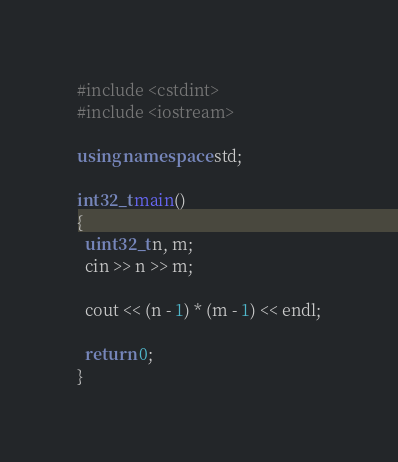Convert code to text. <code><loc_0><loc_0><loc_500><loc_500><_C++_>#include <cstdint>
#include <iostream>

using namespace std;

int32_t main()
{
  uint32_t n, m;
  cin >> n >> m;

  cout << (n - 1) * (m - 1) << endl;

  return 0;
}
</code> 